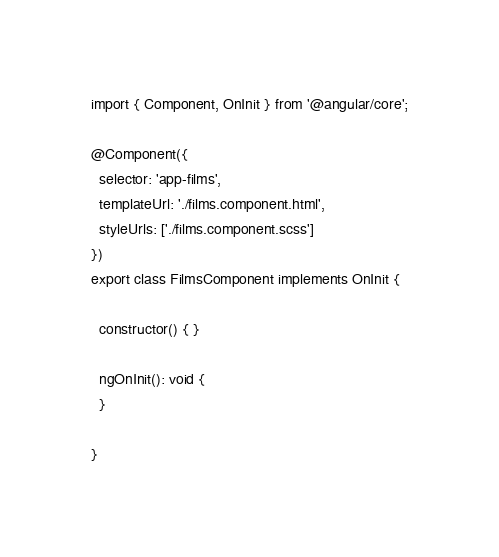Convert code to text. <code><loc_0><loc_0><loc_500><loc_500><_TypeScript_>import { Component, OnInit } from '@angular/core';

@Component({
  selector: 'app-films',
  templateUrl: './films.component.html',
  styleUrls: ['./films.component.scss']
})
export class FilmsComponent implements OnInit {

  constructor() { }

  ngOnInit(): void {
  }

}
</code> 